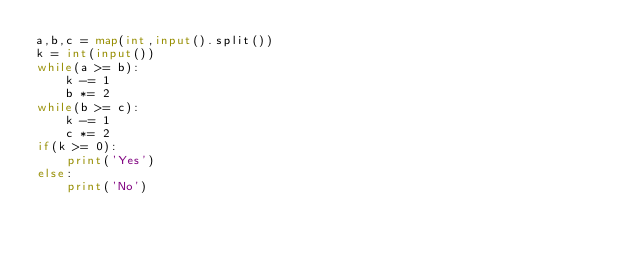Convert code to text. <code><loc_0><loc_0><loc_500><loc_500><_Python_>a,b,c = map(int,input().split())
k = int(input())
while(a >= b):
    k -= 1
    b *= 2
while(b >= c):
    k -= 1
    c *= 2
if(k >= 0):
    print('Yes')
else:
    print('No')</code> 